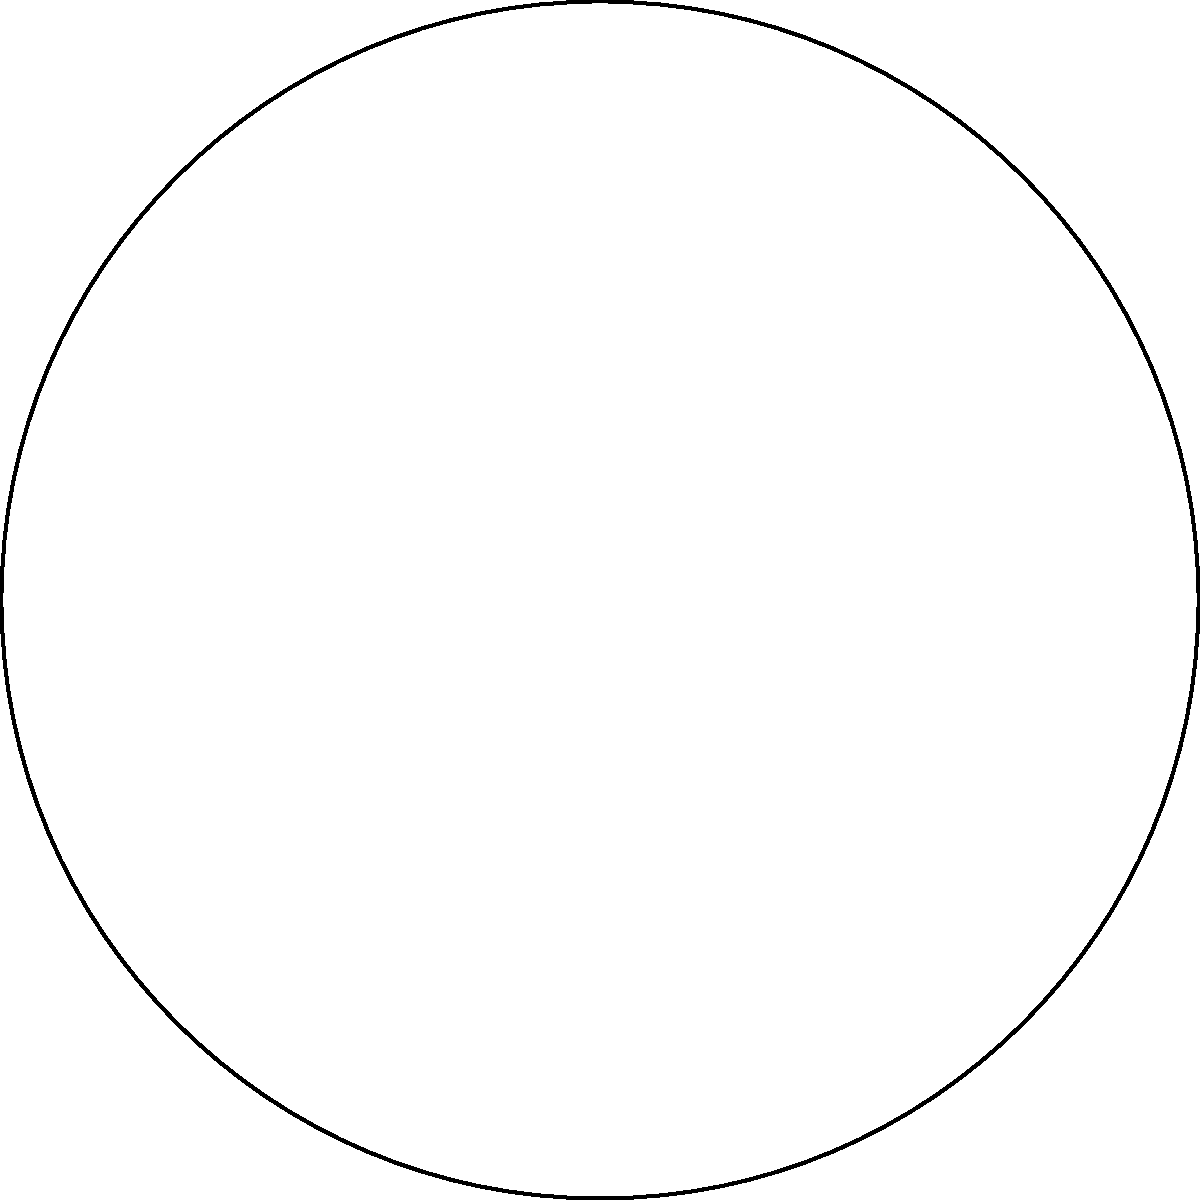In an ancient Roman mosaic floor, archaeologists discovered a circular design with a sector highlighted in a different color. The sector spans an angle of 120°, and the entire circle has a radius of 5 meters. What is the area of the highlighted sector in square meters? Round your answer to two decimal places. To calculate the area of a sector, we need to follow these steps:

1) Recall the formula for the area of a sector:
   $$A = \frac{\theta}{360°} \cdot \pi r^2$$
   where $A$ is the area, $\theta$ is the central angle in degrees, and $r$ is the radius.

2) We are given:
   $\theta = 120°$
   $r = 5$ meters

3) Let's substitute these values into our formula:
   $$A = \frac{120°}{360°} \cdot \pi (5\text{ m})^2$$

4) Simplify the fraction:
   $$A = \frac{1}{3} \cdot \pi (25\text{ m}^2)$$

5) Calculate:
   $$A = \frac{1}{3} \cdot \pi \cdot 25\text{ m}^2 \approx 26.1799\text{ m}^2$$

6) Rounding to two decimal places:
   $$A \approx 26.18\text{ m}^2$$

Thus, the area of the highlighted sector is approximately 26.18 square meters.
Answer: 26.18 m² 